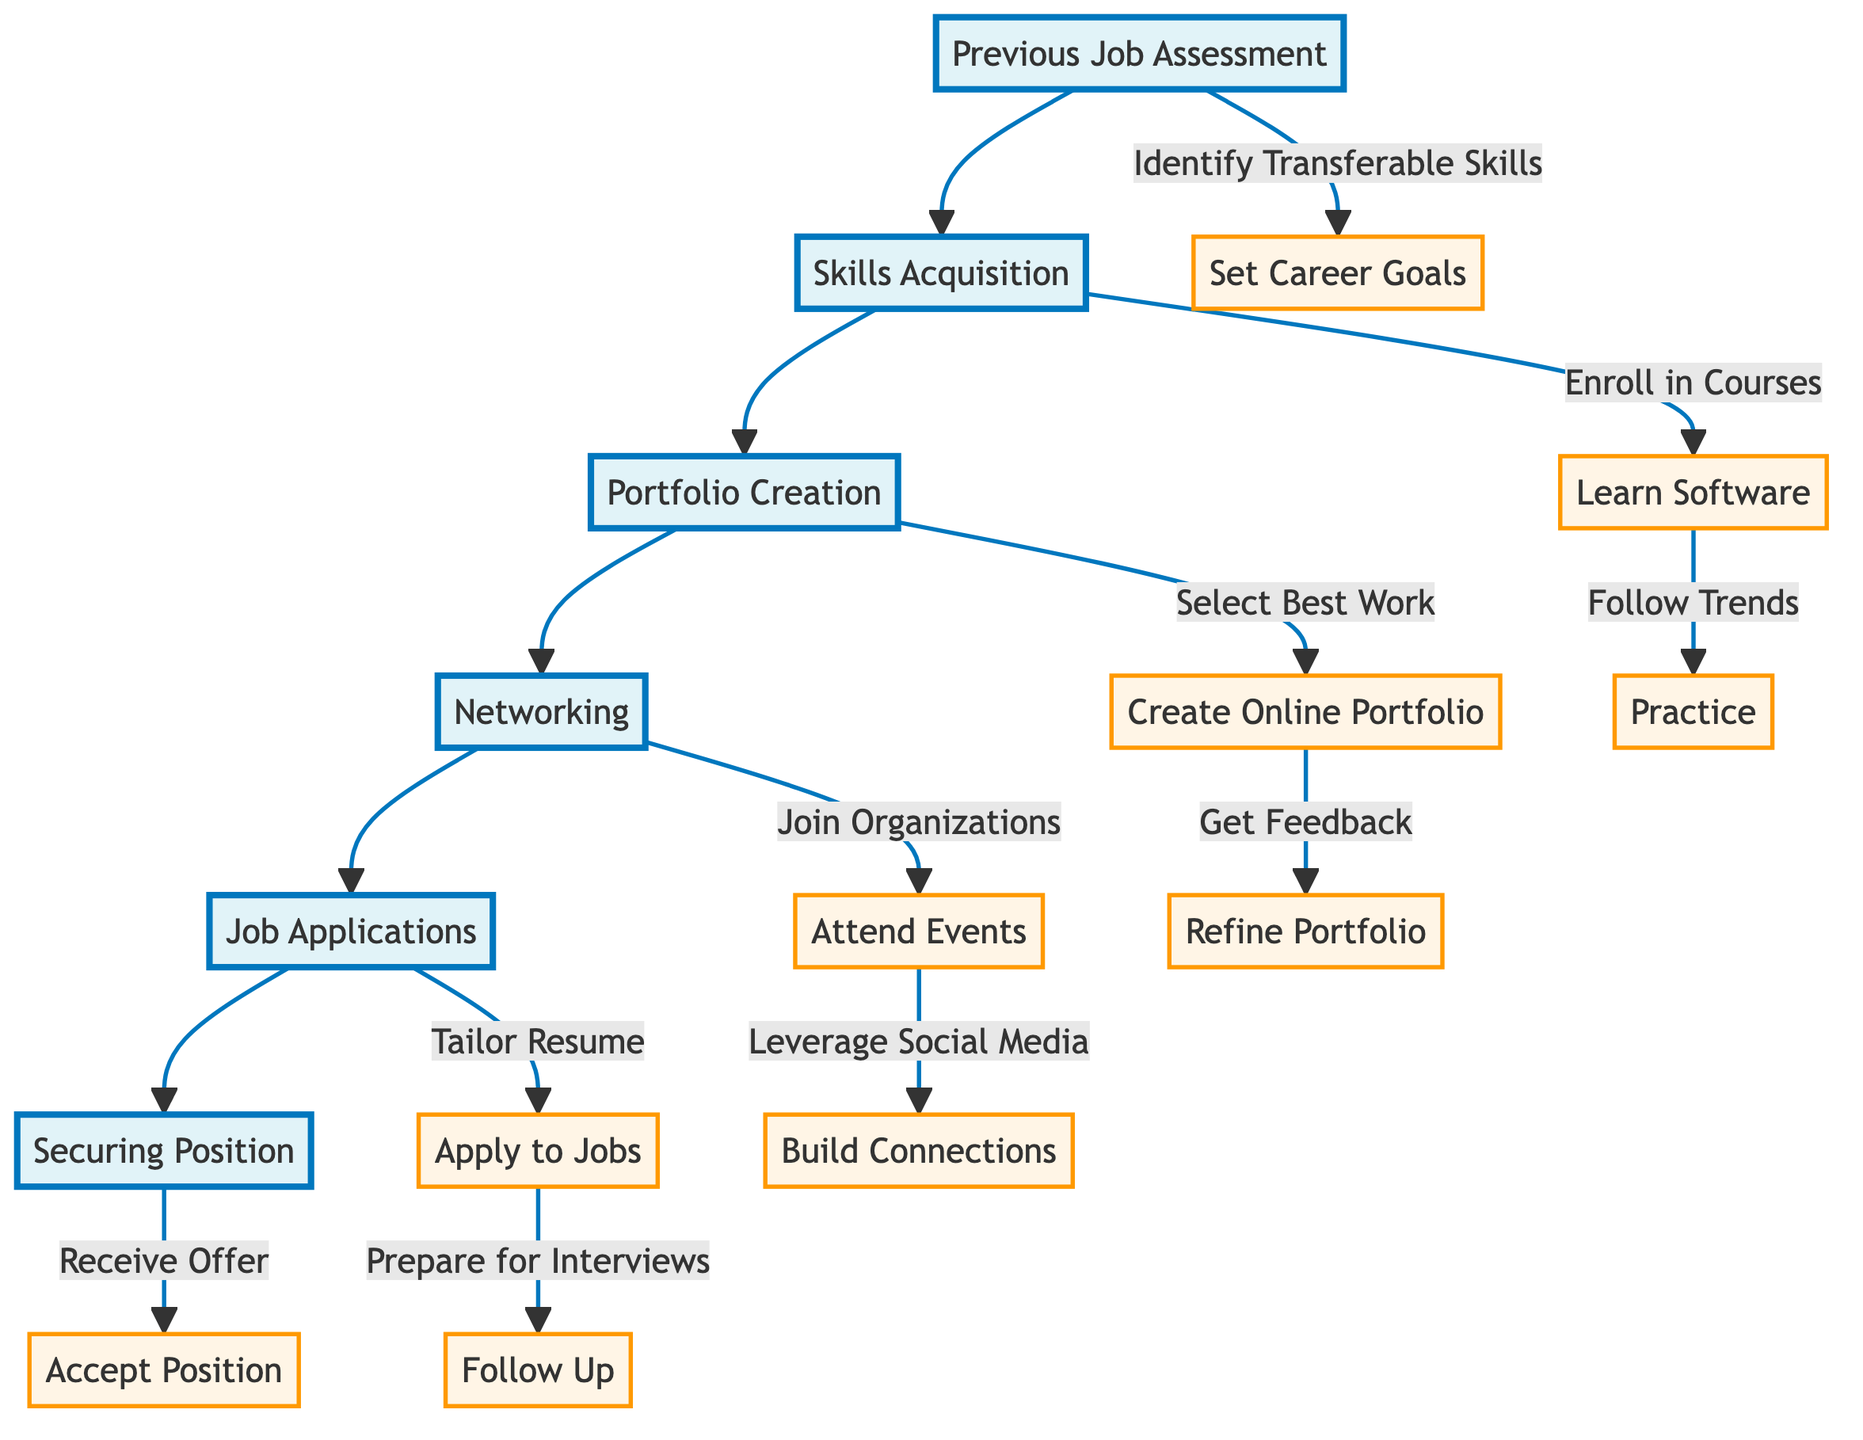What is the first step in the career transition process? The first step in the process is "Previous Job Assessment." This node is positioned at the top of the flow chart, indicating it is the starting point before proceeding to other steps.
Answer: Previous Job Assessment How many main phases are there in the diagram? The diagram consists of five main phases: Previous Job Assessment, Skills Acquisition, Portfolio Creation, Networking, and Job Applications, which leads to Securing Position.
Answer: Five What is the last step in securing a position? The last step is "Accept Position," which is found at the end of the flow chart, indicating it is the final action after receiving a job offer.
Answer: Accept Position Which step follows "Learn Graphic Design Software"? The step following "Learn Graphic Design Software" is "Follow Design Trends," indicating this is the next action to take after learning the software.
Answer: Follow Design Trends How do you build connections in the design industry? You build connections by "Joining Professional Organizations," which is one of the steps listed under the Networking phase. It indicates that becoming a member of professional bodies is a method to enhance networking.
Answer: Join Professional Organizations What is the relationship between Skills Acquisition and Portfolio Creation? The relationship is sequential; after completing the Skills Acquisition phase, the next step in the flow is to move to Portfolio Creation, indicating that skills gained should be showcased.
Answer: Sequential What is required before applying to jobs? Before applying to jobs, "Tailor Resumes and Cover Letters" is needed, which is a preparatory step highlighted under the Job Applications phase indicating the customization of application materials.
Answer: Tailor Resumes and Cover Letters How many steps are in the Portfolio Creation phase? There are three steps listed in the Portfolio Creation phase: Select Best Work, Create Online Portfolio, and Get Feedback, summarizing the essential activities for portfolio development.
Answer: Three What do you do after you "Receive Job Offer"? After "Receive Job Offer," the next action is to "Accept Position," signifying the progression towards official employment following an offer.
Answer: Accept Position 